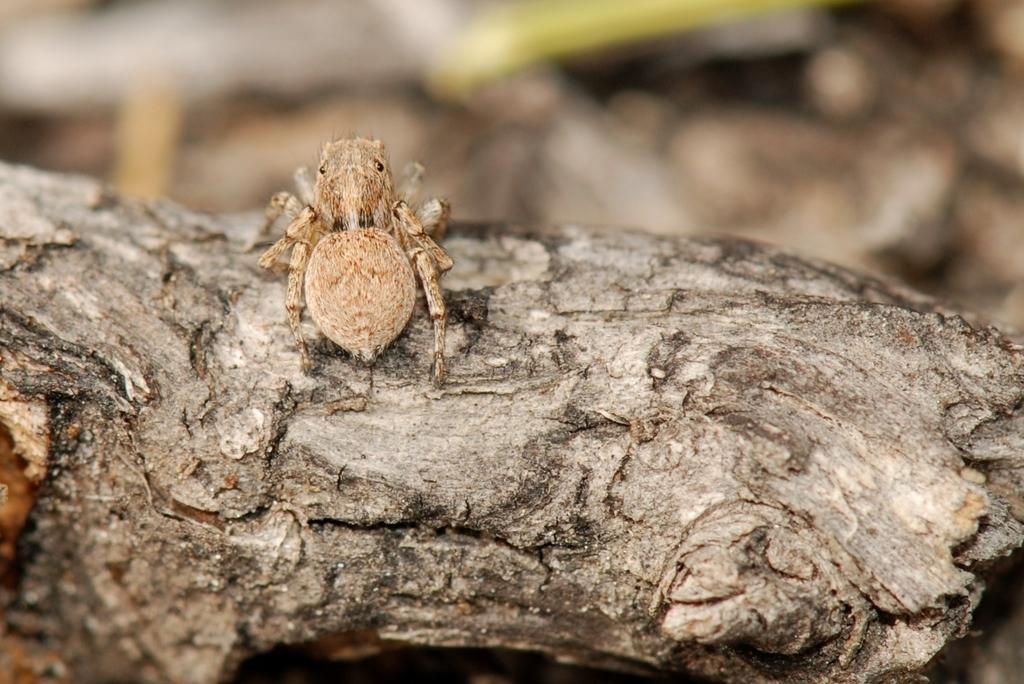Describe this image in one or two sentences. In this picture we can see an insect on a wooden branch of a tree. Background is blurry. 